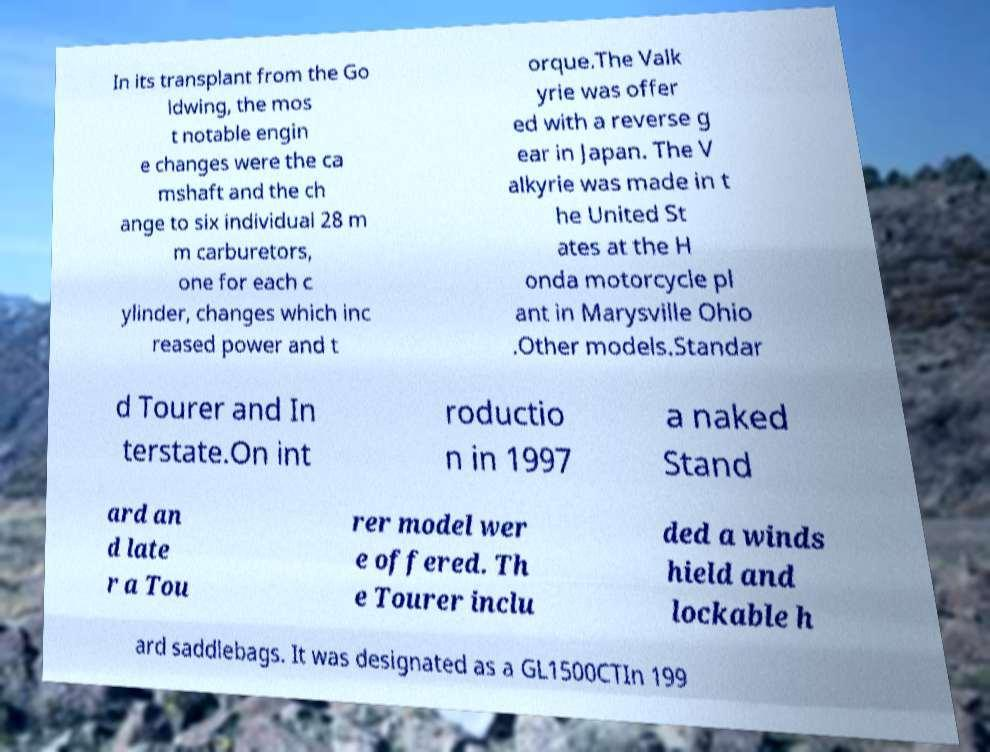I need the written content from this picture converted into text. Can you do that? In its transplant from the Go ldwing, the mos t notable engin e changes were the ca mshaft and the ch ange to six individual 28 m m carburetors, one for each c ylinder, changes which inc reased power and t orque.The Valk yrie was offer ed with a reverse g ear in Japan. The V alkyrie was made in t he United St ates at the H onda motorcycle pl ant in Marysville Ohio .Other models.Standar d Tourer and In terstate.On int roductio n in 1997 a naked Stand ard an d late r a Tou rer model wer e offered. Th e Tourer inclu ded a winds hield and lockable h ard saddlebags. It was designated as a GL1500CTIn 199 